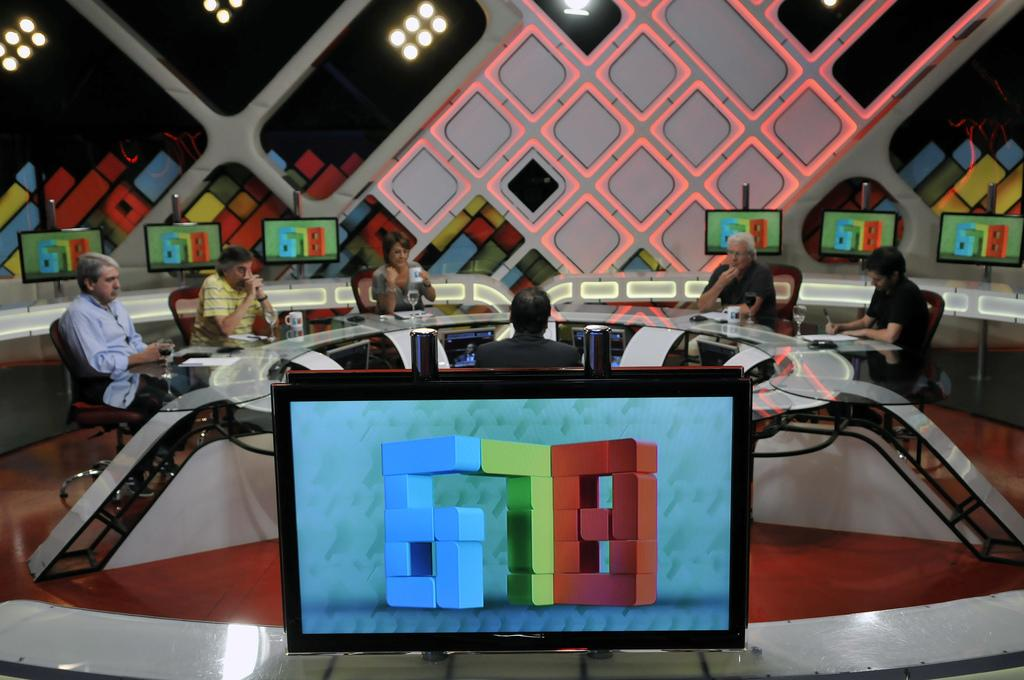<image>
Give a short and clear explanation of the subsequent image. People sit around a rounded table with screens in front of and behind them that say 678 in blocky letters. 